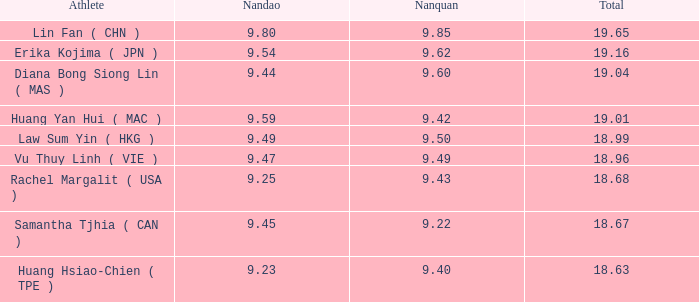Which Nanquan has a Nandao larger than 9.49, and a Rank of 4? 9.42. 